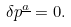<formula> <loc_0><loc_0><loc_500><loc_500>\delta p ^ { \underline { a } } = 0 .</formula> 